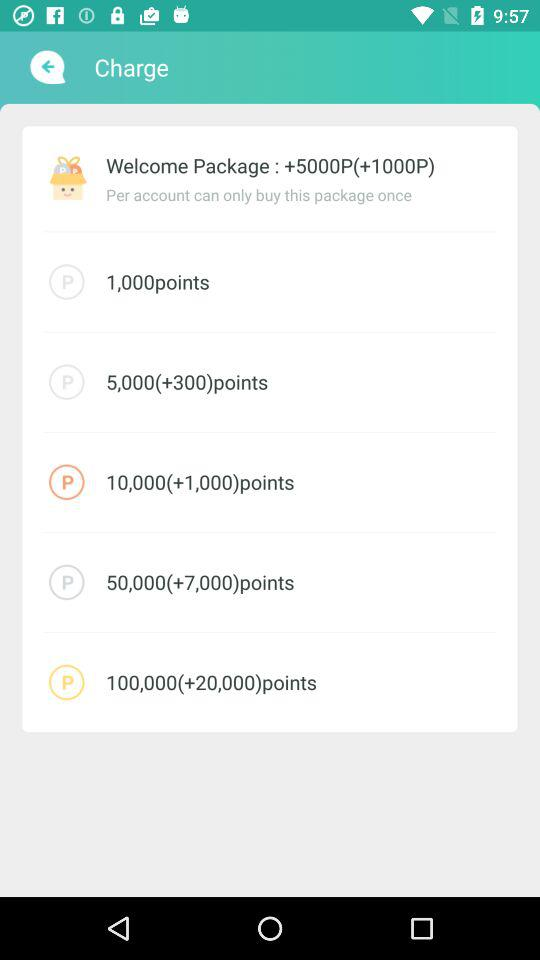How many more points are included in the 100,000 points package than the 50,000 points package?
Answer the question using a single word or phrase. 50000 